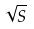<formula> <loc_0><loc_0><loc_500><loc_500>\sqrt { S }</formula> 